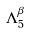Convert formula to latex. <formula><loc_0><loc_0><loc_500><loc_500>\Lambda _ { 5 } ^ { \beta }</formula> 